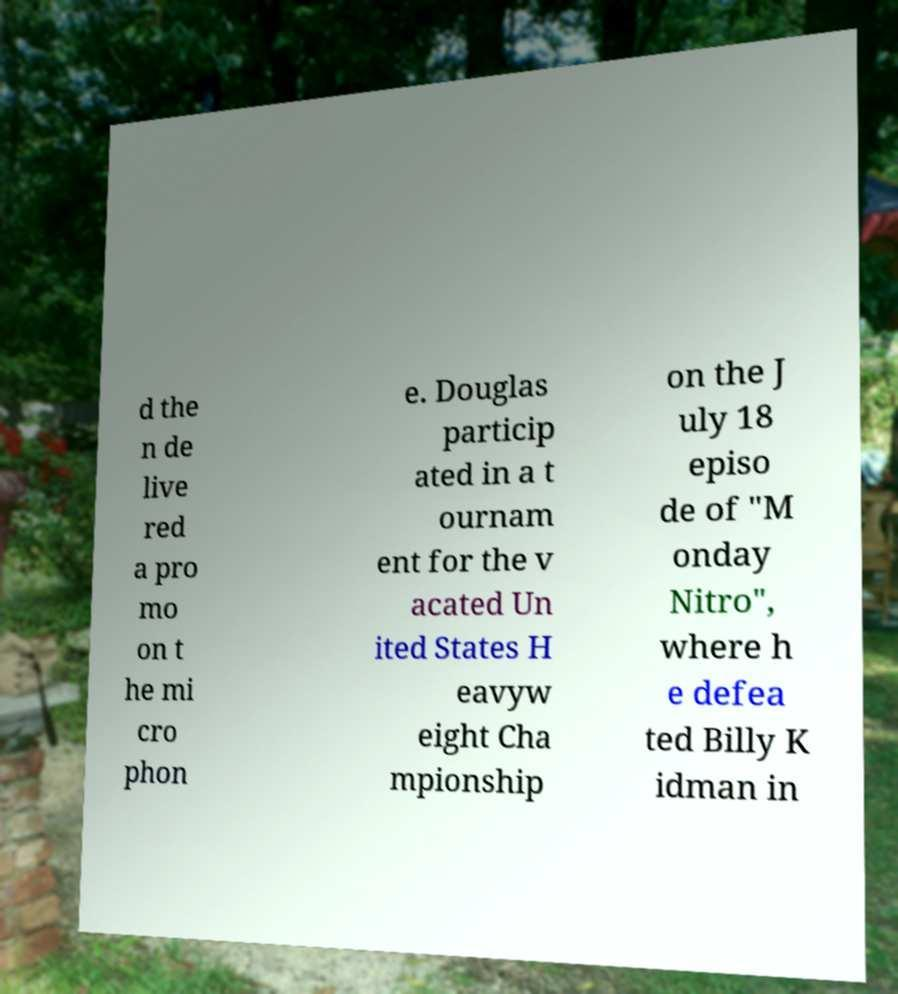There's text embedded in this image that I need extracted. Can you transcribe it verbatim? d the n de live red a pro mo on t he mi cro phon e. Douglas particip ated in a t ournam ent for the v acated Un ited States H eavyw eight Cha mpionship on the J uly 18 episo de of "M onday Nitro", where h e defea ted Billy K idman in 